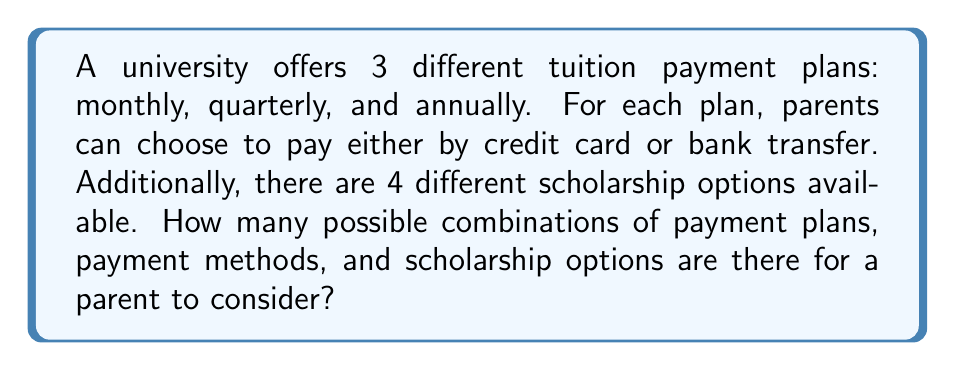Can you answer this question? Let's break this down step-by-step:

1) First, we need to identify the number of choices for each category:
   - Payment plans: 3 (monthly, quarterly, annually)
   - Payment methods: 2 (credit card, bank transfer)
   - Scholarship options: 4

2) Now, we need to apply the multiplication principle of counting. This principle states that if we have $m$ ways of doing something, $n$ ways of doing another thing, and $p$ ways of doing a third thing, then there are $m \times n \times p$ ways to do all three things.

3) In this case, we have:
   - 3 choices for payment plans
   - 2 choices for payment methods
   - 4 choices for scholarship options

4) Therefore, the total number of possible combinations is:

   $$ 3 \times 2 \times 4 = 24 $$

This means there are 24 different possible combinations of payment plans, payment methods, and scholarship options for a parent to consider.
Answer: 24 